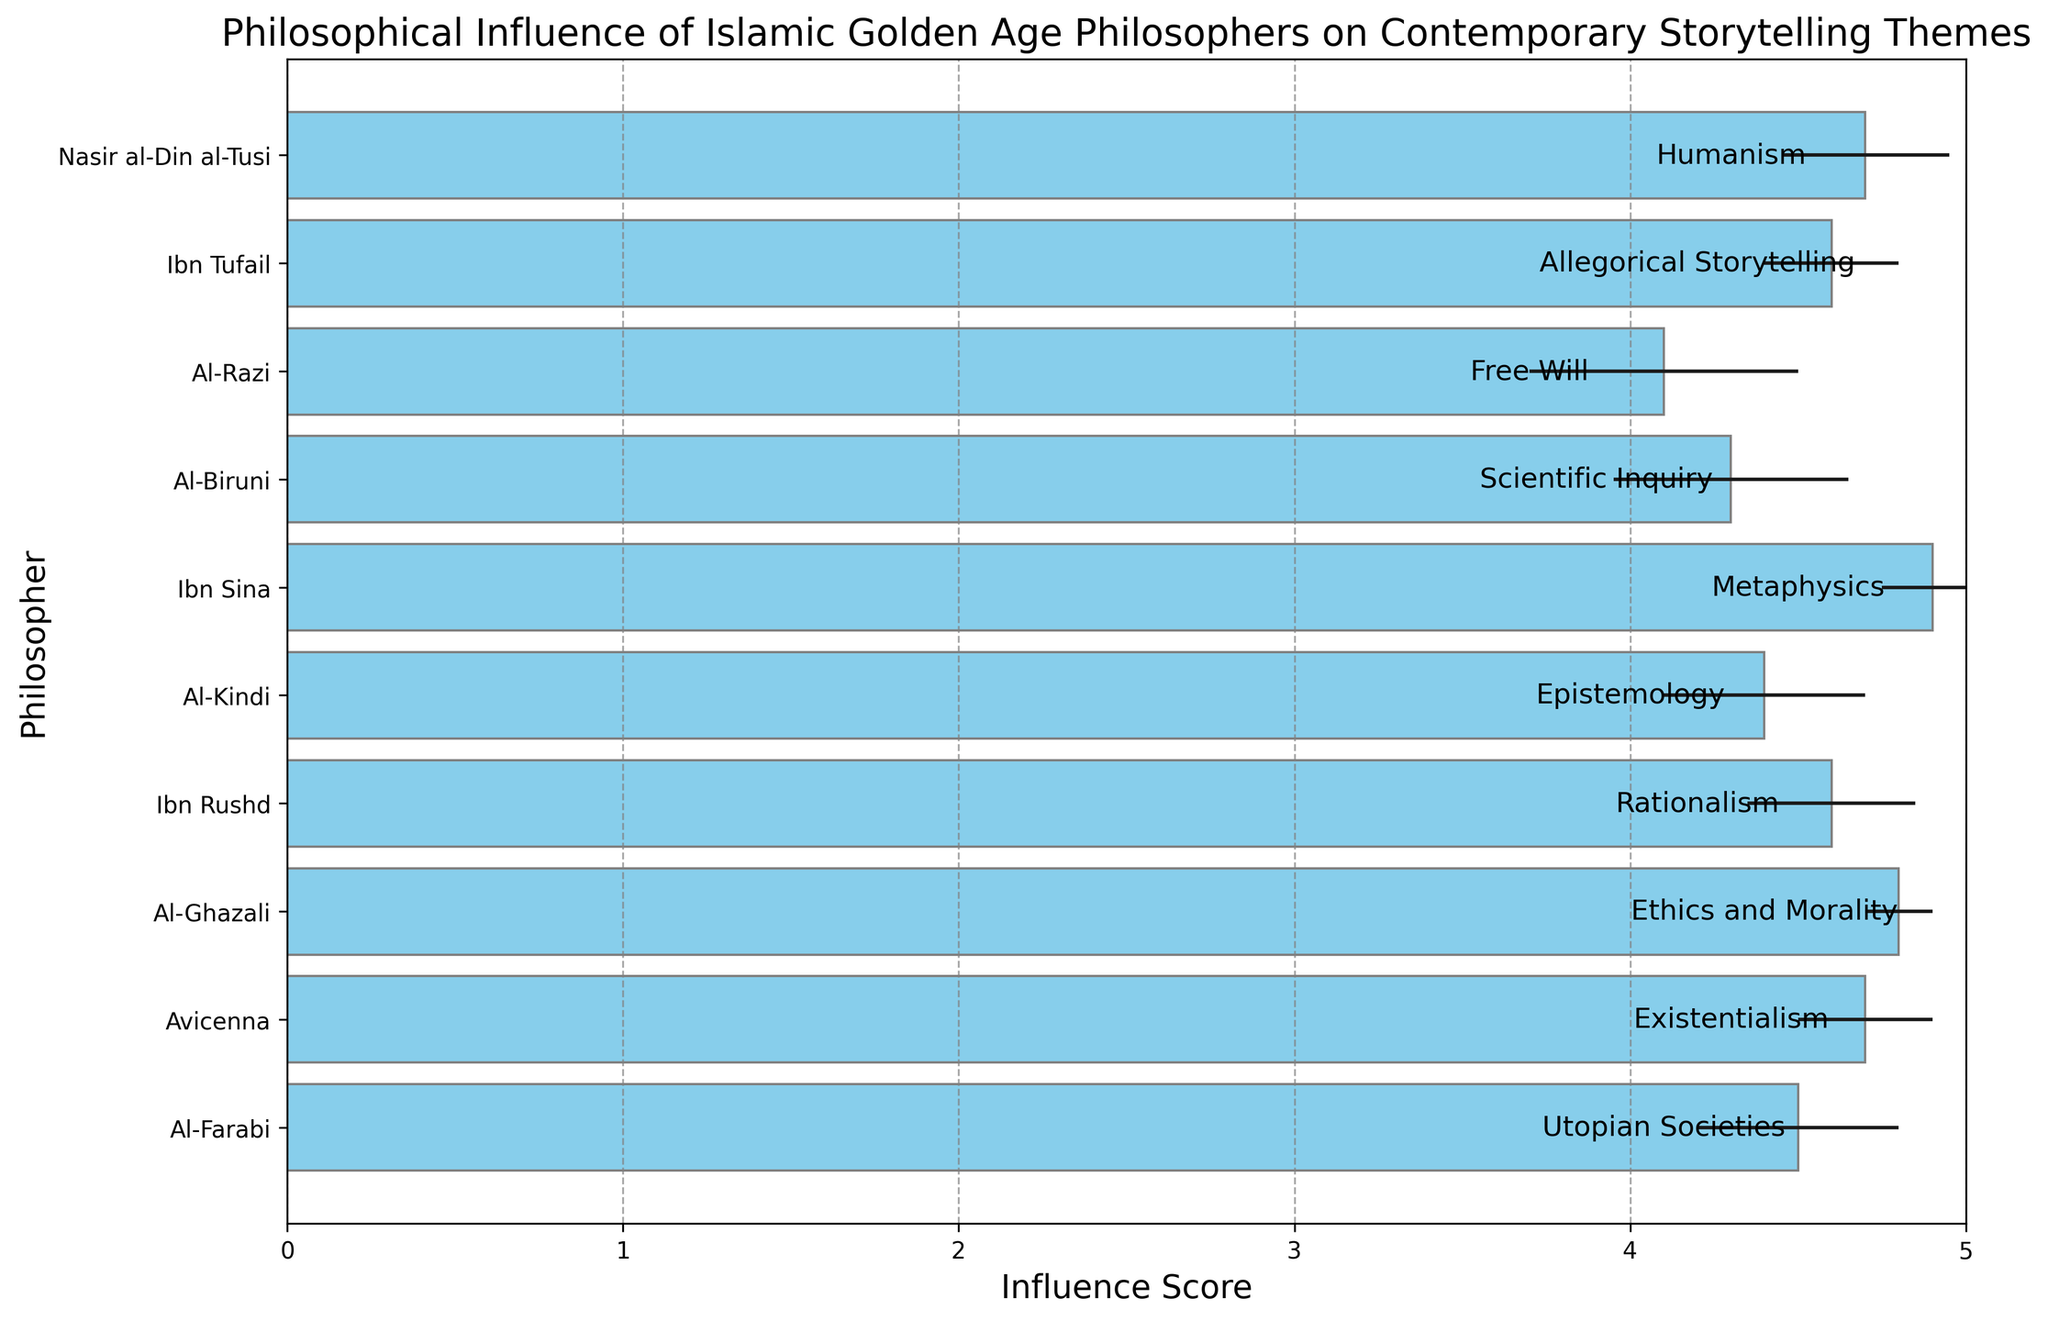What theme is associated with Al-Ghazali, and what is his influence score? Al-Ghazali is associated with the theme "Ethics and Morality". According to the figure, his influence score is 4.8.
Answer: "Ethics and Morality", 4.8 Which philosopher has the least influence score, and what is the score? Al-Razi has the least influence score. According to the figure, his score is 4.1.
Answer: Al-Razi, 4.1 Which two philosophers have the same influence score, and what is the theme associated with each? Ibn Rushd and Ibn Tufail both have an influence score of 4.6. Ibn Rushd's theme is "Rationalism", and Ibn Tufail's theme is "Allegorical Storytelling".
Answer: Ibn Rushd: "Rationalism", Ibn Tufail: "Allegorical Storytelling" What is the average influence score of Al-Farabi, Avicenna, and Al-Ghazali? The influence scores of Al-Farabi, Avicenna, and Al-Ghazali are 4.5, 4.7, and 4.8, respectively. The average influence score is (4.5 + 4.7 + 4.8) / 3 = 4.67.
Answer: 4.67 Which philosopher has the smallest error in their influence score, and what is the theme associated with this philosopher? Al-Ghazali has the smallest error in his influence score, which is 0.1. He is associated with the theme "Ethics and Morality".
Answer: Al-Ghazali, "Ethics and Morality" Order the influence scores of the philosophers from highest to lowest. Which philosopher is in the third position? The influence scores in descending order are Ibn Sina (4.9), Al-Ghazali (4.8), Avicenna (4.7), Nasir al-Din al-Tusi (4.7), Ibn Rushd (4.6), Ibn Tufail (4.6), Al-Farabi (4.5), Al-Kindi (4.4), Al-Biruni (4.3), Al-Razi (4.1). Nasir al-Din al-Tusi is in the third position.
Answer: Nasir al-Din al-Tusi What is the total influence score of all philosophers combined? The total influence score is the sum of all individual scores: 4.5 + 4.7 + 4.8 + 4.6 + 4.4 + 4.9 + 4.3 + 4.1 + 4.6 + 4.7 = 45.6.
Answer: 45.6 What's the difference between the highest and lowest influence scores? The highest influence score is 4.9 (Ibn Sina), and the lowest is 4.1 (Al-Razi). The difference is 4.9 - 4.1 = 0.8.
Answer: 0.8 Which philosopher is associated with the theme "Rationalism", and what is his influence score and error margin? Ibn Rushd is associated with the theme "Rationalism". His influence score is 4.6, and his error margin is 0.25.
Answer: Ibn Rushd, 4.6, 0.25 